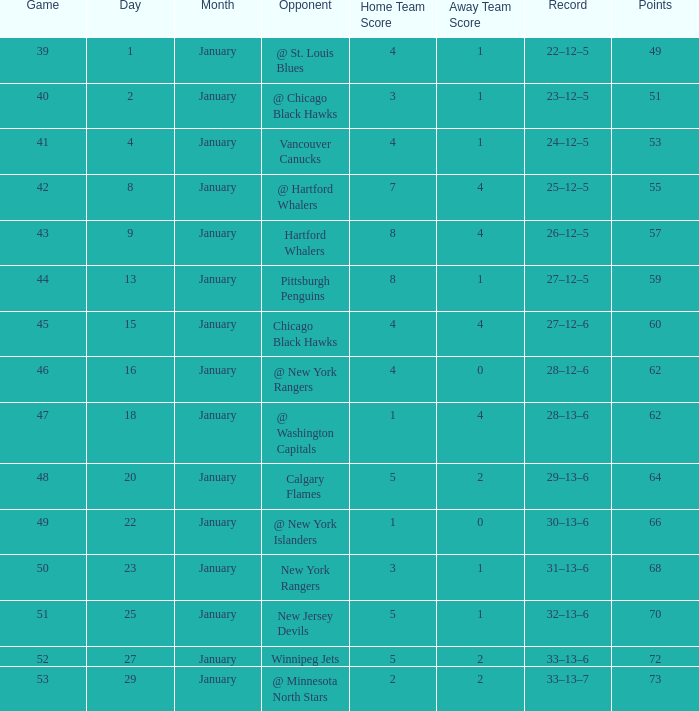Which Points have a Score of 4–1, and a Game smaller than 39? None. 